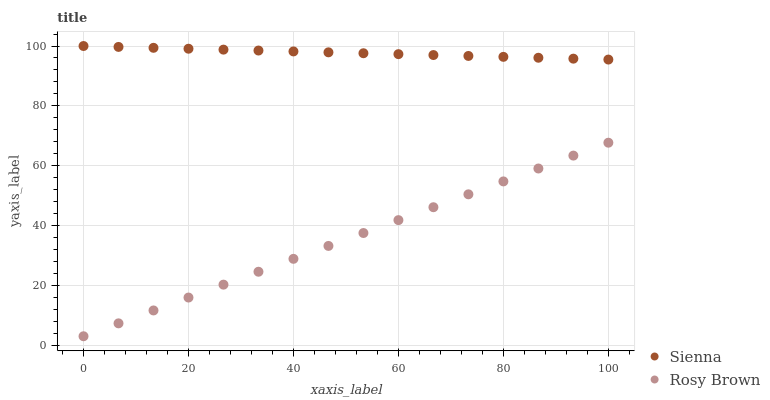Does Rosy Brown have the minimum area under the curve?
Answer yes or no. Yes. Does Sienna have the maximum area under the curve?
Answer yes or no. Yes. Does Rosy Brown have the maximum area under the curve?
Answer yes or no. No. Is Rosy Brown the smoothest?
Answer yes or no. Yes. Is Sienna the roughest?
Answer yes or no. Yes. Is Rosy Brown the roughest?
Answer yes or no. No. Does Rosy Brown have the lowest value?
Answer yes or no. Yes. Does Sienna have the highest value?
Answer yes or no. Yes. Does Rosy Brown have the highest value?
Answer yes or no. No. Is Rosy Brown less than Sienna?
Answer yes or no. Yes. Is Sienna greater than Rosy Brown?
Answer yes or no. Yes. Does Rosy Brown intersect Sienna?
Answer yes or no. No. 